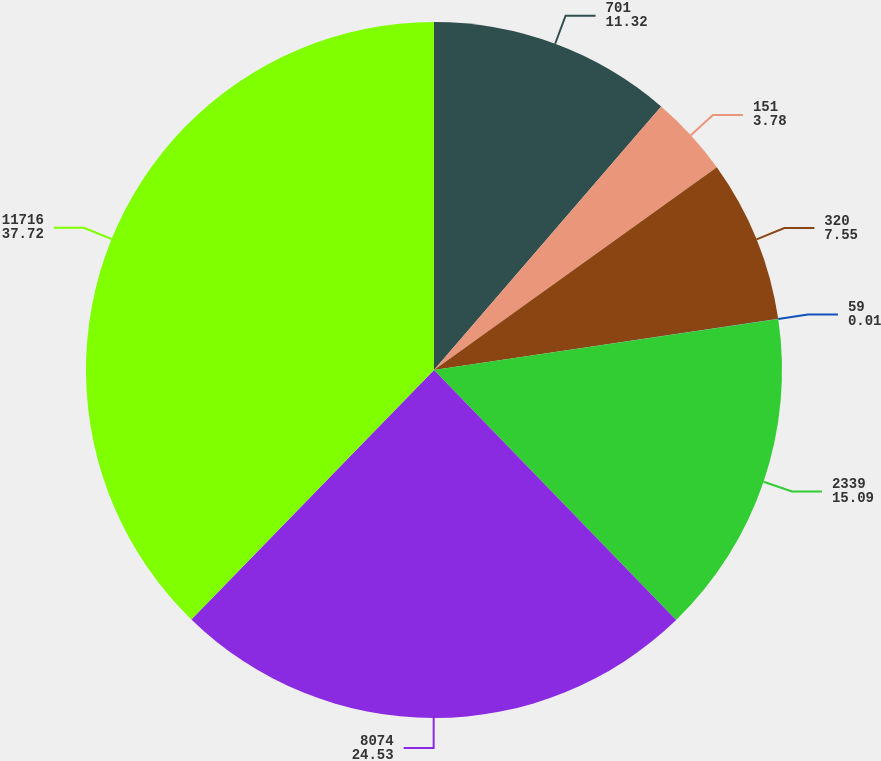Convert chart to OTSL. <chart><loc_0><loc_0><loc_500><loc_500><pie_chart><fcel>701<fcel>151<fcel>320<fcel>59<fcel>2339<fcel>8074<fcel>11716<nl><fcel>11.32%<fcel>3.78%<fcel>7.55%<fcel>0.01%<fcel>15.09%<fcel>24.53%<fcel>37.72%<nl></chart> 